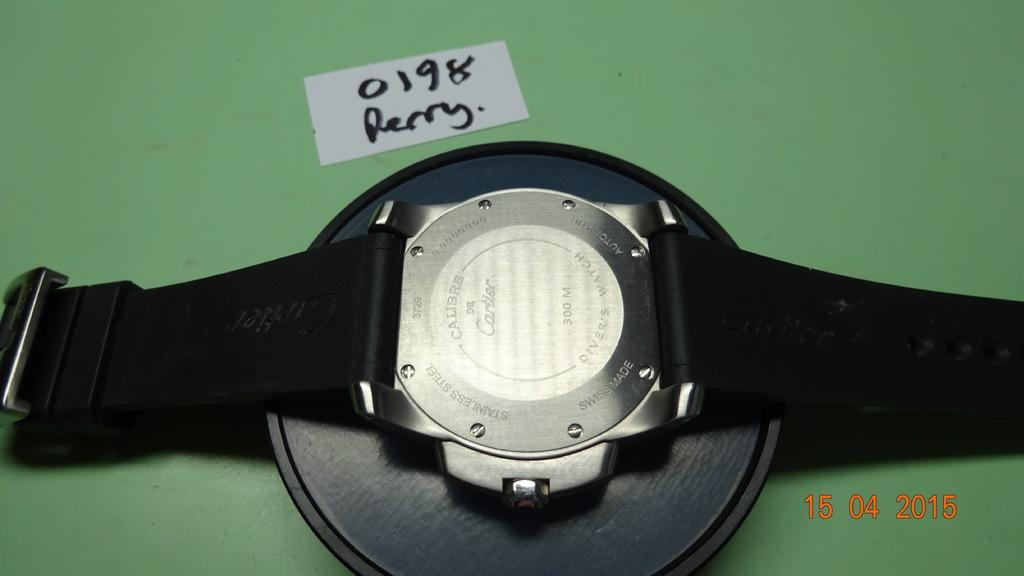<image>
Summarize the visual content of the image. Watch next to a white piece of paper which says Perry. 